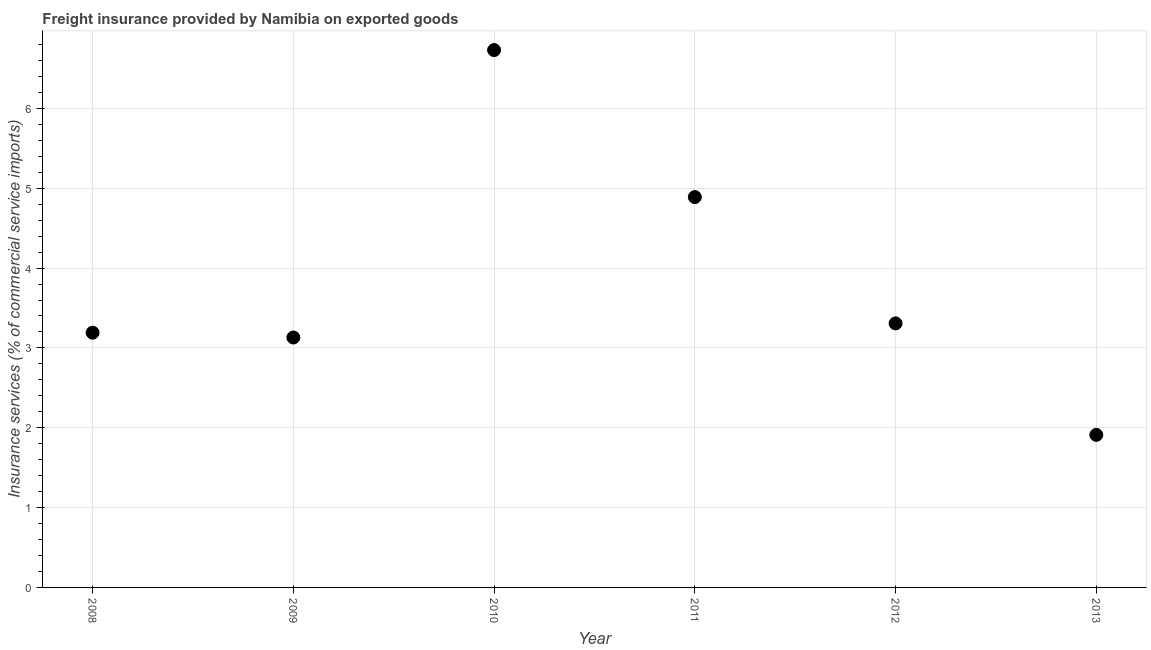What is the freight insurance in 2009?
Provide a short and direct response. 3.13. Across all years, what is the maximum freight insurance?
Your answer should be very brief. 6.73. Across all years, what is the minimum freight insurance?
Make the answer very short. 1.91. In which year was the freight insurance minimum?
Your response must be concise. 2013. What is the sum of the freight insurance?
Provide a succinct answer. 23.16. What is the difference between the freight insurance in 2011 and 2013?
Your answer should be compact. 2.98. What is the average freight insurance per year?
Your response must be concise. 3.86. What is the median freight insurance?
Ensure brevity in your answer.  3.25. Do a majority of the years between 2013 and 2011 (inclusive) have freight insurance greater than 5.4 %?
Provide a short and direct response. No. What is the ratio of the freight insurance in 2009 to that in 2012?
Ensure brevity in your answer.  0.95. Is the difference between the freight insurance in 2009 and 2013 greater than the difference between any two years?
Your answer should be compact. No. What is the difference between the highest and the second highest freight insurance?
Your answer should be very brief. 1.84. What is the difference between the highest and the lowest freight insurance?
Keep it short and to the point. 4.82. Does the freight insurance monotonically increase over the years?
Offer a very short reply. No. What is the title of the graph?
Offer a very short reply. Freight insurance provided by Namibia on exported goods . What is the label or title of the X-axis?
Give a very brief answer. Year. What is the label or title of the Y-axis?
Make the answer very short. Insurance services (% of commercial service imports). What is the Insurance services (% of commercial service imports) in 2008?
Ensure brevity in your answer.  3.19. What is the Insurance services (% of commercial service imports) in 2009?
Your answer should be very brief. 3.13. What is the Insurance services (% of commercial service imports) in 2010?
Your response must be concise. 6.73. What is the Insurance services (% of commercial service imports) in 2011?
Ensure brevity in your answer.  4.89. What is the Insurance services (% of commercial service imports) in 2012?
Provide a succinct answer. 3.31. What is the Insurance services (% of commercial service imports) in 2013?
Make the answer very short. 1.91. What is the difference between the Insurance services (% of commercial service imports) in 2008 and 2009?
Give a very brief answer. 0.06. What is the difference between the Insurance services (% of commercial service imports) in 2008 and 2010?
Give a very brief answer. -3.54. What is the difference between the Insurance services (% of commercial service imports) in 2008 and 2011?
Keep it short and to the point. -1.7. What is the difference between the Insurance services (% of commercial service imports) in 2008 and 2012?
Provide a succinct answer. -0.12. What is the difference between the Insurance services (% of commercial service imports) in 2008 and 2013?
Your response must be concise. 1.28. What is the difference between the Insurance services (% of commercial service imports) in 2009 and 2010?
Keep it short and to the point. -3.6. What is the difference between the Insurance services (% of commercial service imports) in 2009 and 2011?
Provide a succinct answer. -1.76. What is the difference between the Insurance services (% of commercial service imports) in 2009 and 2012?
Offer a terse response. -0.18. What is the difference between the Insurance services (% of commercial service imports) in 2009 and 2013?
Keep it short and to the point. 1.22. What is the difference between the Insurance services (% of commercial service imports) in 2010 and 2011?
Offer a very short reply. 1.84. What is the difference between the Insurance services (% of commercial service imports) in 2010 and 2012?
Make the answer very short. 3.42. What is the difference between the Insurance services (% of commercial service imports) in 2010 and 2013?
Give a very brief answer. 4.82. What is the difference between the Insurance services (% of commercial service imports) in 2011 and 2012?
Offer a very short reply. 1.58. What is the difference between the Insurance services (% of commercial service imports) in 2011 and 2013?
Provide a short and direct response. 2.98. What is the difference between the Insurance services (% of commercial service imports) in 2012 and 2013?
Give a very brief answer. 1.4. What is the ratio of the Insurance services (% of commercial service imports) in 2008 to that in 2009?
Provide a short and direct response. 1.02. What is the ratio of the Insurance services (% of commercial service imports) in 2008 to that in 2010?
Your response must be concise. 0.47. What is the ratio of the Insurance services (% of commercial service imports) in 2008 to that in 2011?
Make the answer very short. 0.65. What is the ratio of the Insurance services (% of commercial service imports) in 2008 to that in 2013?
Your answer should be compact. 1.67. What is the ratio of the Insurance services (% of commercial service imports) in 2009 to that in 2010?
Offer a terse response. 0.47. What is the ratio of the Insurance services (% of commercial service imports) in 2009 to that in 2011?
Your response must be concise. 0.64. What is the ratio of the Insurance services (% of commercial service imports) in 2009 to that in 2012?
Offer a terse response. 0.95. What is the ratio of the Insurance services (% of commercial service imports) in 2009 to that in 2013?
Give a very brief answer. 1.64. What is the ratio of the Insurance services (% of commercial service imports) in 2010 to that in 2011?
Give a very brief answer. 1.38. What is the ratio of the Insurance services (% of commercial service imports) in 2010 to that in 2012?
Provide a succinct answer. 2.04. What is the ratio of the Insurance services (% of commercial service imports) in 2010 to that in 2013?
Offer a terse response. 3.52. What is the ratio of the Insurance services (% of commercial service imports) in 2011 to that in 2012?
Offer a terse response. 1.48. What is the ratio of the Insurance services (% of commercial service imports) in 2011 to that in 2013?
Give a very brief answer. 2.56. What is the ratio of the Insurance services (% of commercial service imports) in 2012 to that in 2013?
Your answer should be very brief. 1.73. 